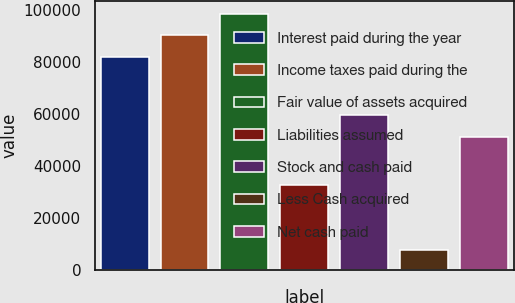<chart> <loc_0><loc_0><loc_500><loc_500><bar_chart><fcel>Interest paid during the year<fcel>Income taxes paid during the<fcel>Fair value of assets acquired<fcel>Liabilities assumed<fcel>Stock and cash paid<fcel>Less Cash acquired<fcel>Net cash paid<nl><fcel>81756<fcel>90162.1<fcel>98568.2<fcel>32908<fcel>59559.1<fcel>7697<fcel>51153<nl></chart> 